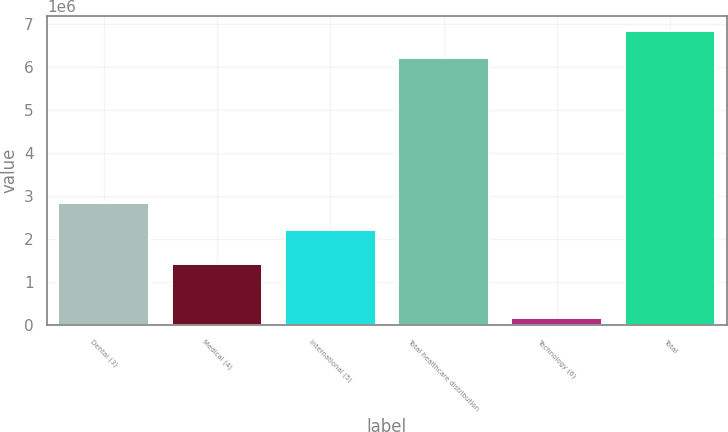<chart> <loc_0><loc_0><loc_500><loc_500><bar_chart><fcel>Dental (3)<fcel>Medical (4)<fcel>International (5)<fcel>Total healthcare distribution<fcel>Technology (6)<fcel>Total<nl><fcel>2.8428e+06<fcel>1.42897e+06<fcel>2.22109e+06<fcel>6.21712e+06<fcel>163289<fcel>6.83884e+06<nl></chart> 